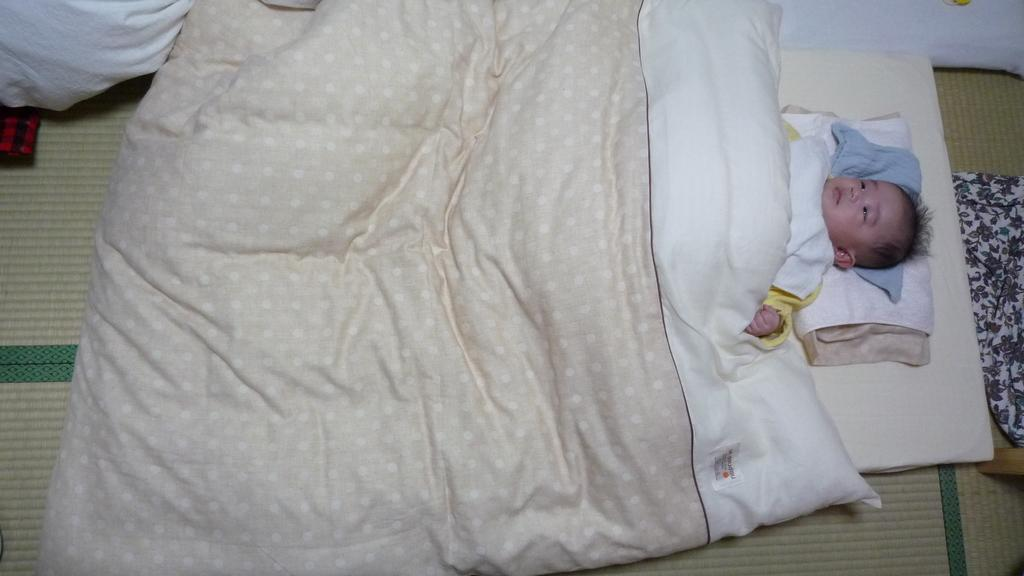What is the main subject of the image? There is a baby lying on the bed in the image. What is covering the baby? There is a blanket in the image. What is on the floor in the image? There is a mat on the floor in the image. What type of jewel is the baby wearing on their feet in the image? There is no jewel or any indication of the baby wearing anything on their feet in the image. 